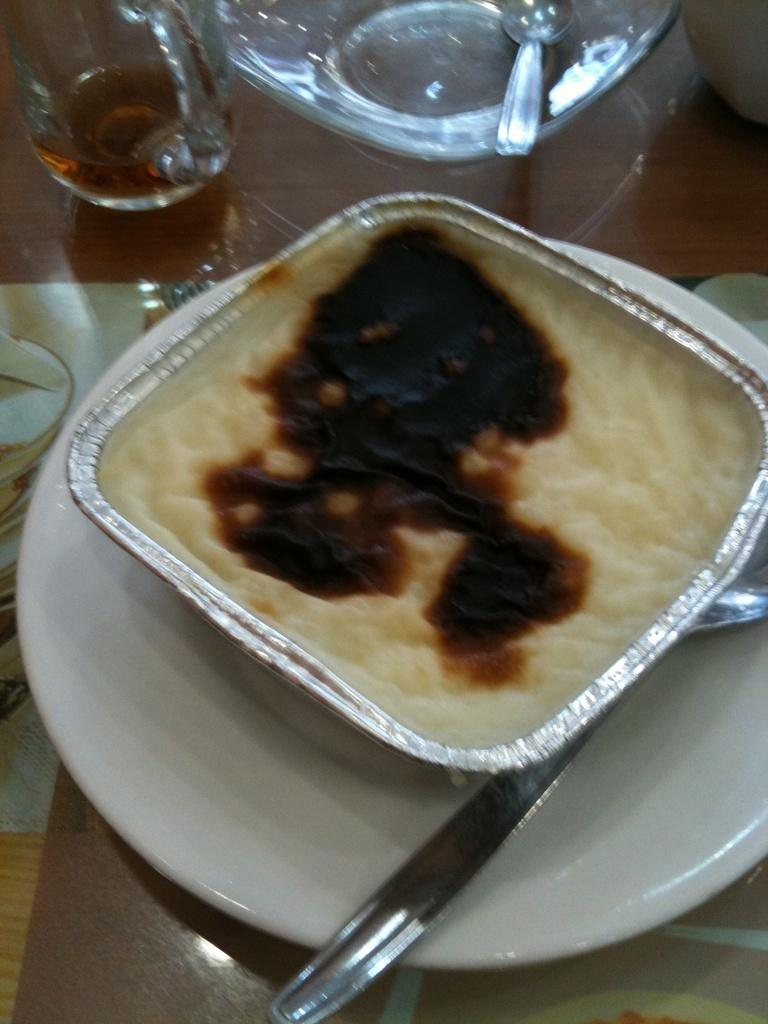What type of glassware is on the table in the image? There is a wine glass on the table in the image. What other type of container is on the table? There is a cup on the table. What sports equipment is on the table? There is a soccer ball on the table. What is used to serve food on the table? There are plates on the table. What is placed under the objects on the table? There is a mat on the table. What else can be seen on the table besides the mentioned items? There are other objects on the table. What is the main item in the center of the table? There is a box with food items in the center of the table. How many babies are crawling under the table in the image? There are no babies present in the image; it only shows objects on the table. What type of shade is covering the table in the image? There is no shade covering the table in the image. 